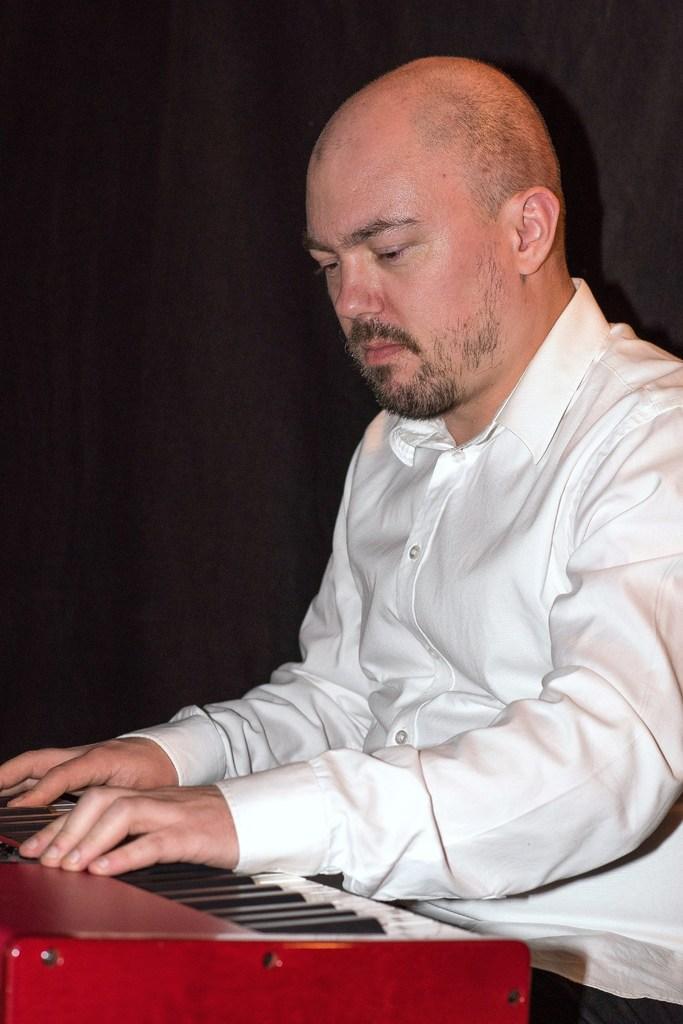Describe this image in one or two sentences. In this image we can see a person playing a musical instrument. At the background we can see a black colored curtain. 